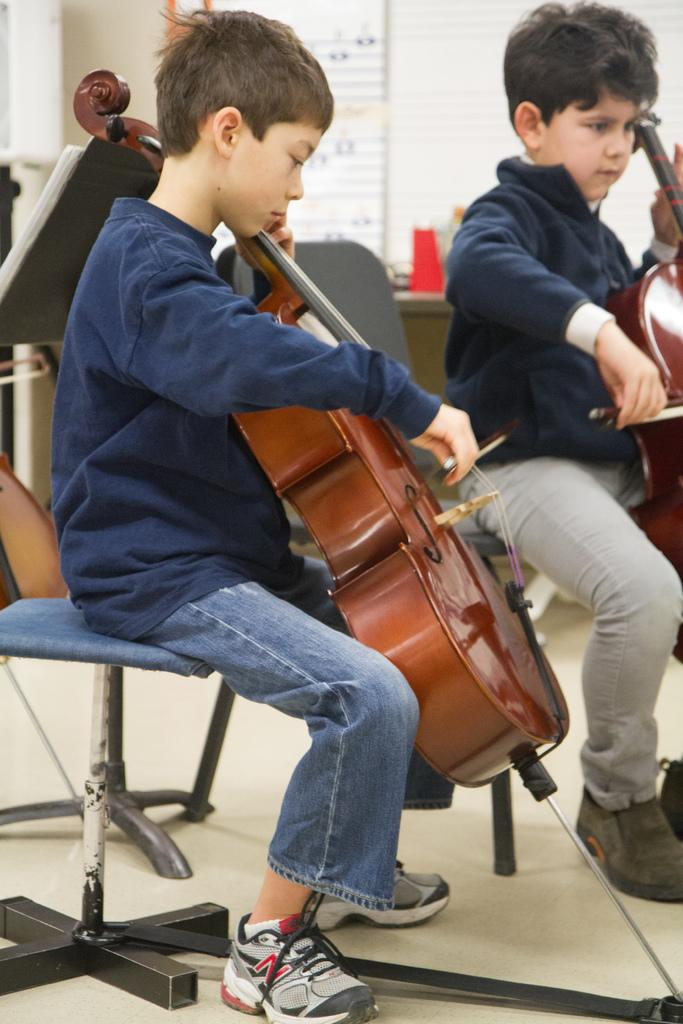How many boys are in the image? There are two boys in the image. What are the boys doing in the image? The boys are sitting on chairs and playing the violin. Can you describe the background of the image? There is a chair, a table, a window, and papers in the background of the image. What type of quilt can be seen on the window in the image? There is no quilt present in the image, and the window is not covered by any quilt. 